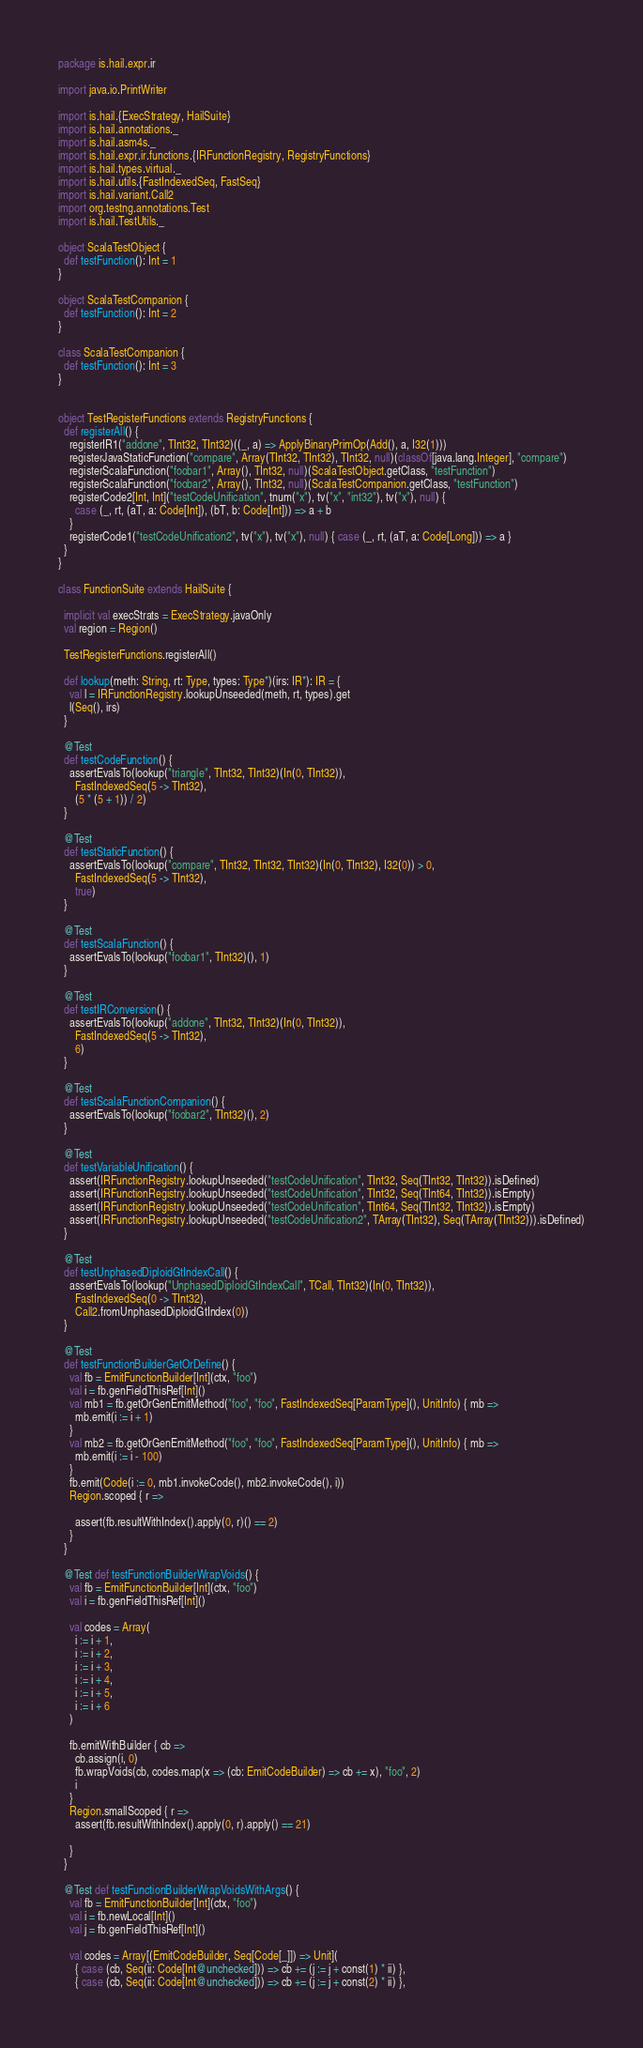<code> <loc_0><loc_0><loc_500><loc_500><_Scala_>package is.hail.expr.ir

import java.io.PrintWriter

import is.hail.{ExecStrategy, HailSuite}
import is.hail.annotations._
import is.hail.asm4s._
import is.hail.expr.ir.functions.{IRFunctionRegistry, RegistryFunctions}
import is.hail.types.virtual._
import is.hail.utils.{FastIndexedSeq, FastSeq}
import is.hail.variant.Call2
import org.testng.annotations.Test
import is.hail.TestUtils._

object ScalaTestObject {
  def testFunction(): Int = 1
}

object ScalaTestCompanion {
  def testFunction(): Int = 2
}

class ScalaTestCompanion {
  def testFunction(): Int = 3
}


object TestRegisterFunctions extends RegistryFunctions {
  def registerAll() {
    registerIR1("addone", TInt32, TInt32)((_, a) => ApplyBinaryPrimOp(Add(), a, I32(1)))
    registerJavaStaticFunction("compare", Array(TInt32, TInt32), TInt32, null)(classOf[java.lang.Integer], "compare")
    registerScalaFunction("foobar1", Array(), TInt32, null)(ScalaTestObject.getClass, "testFunction")
    registerScalaFunction("foobar2", Array(), TInt32, null)(ScalaTestCompanion.getClass, "testFunction")
    registerCode2[Int, Int]("testCodeUnification", tnum("x"), tv("x", "int32"), tv("x"), null) {
      case (_, rt, (aT, a: Code[Int]), (bT, b: Code[Int])) => a + b
    }
    registerCode1("testCodeUnification2", tv("x"), tv("x"), null) { case (_, rt, (aT, a: Code[Long])) => a }
  }
}

class FunctionSuite extends HailSuite {

  implicit val execStrats = ExecStrategy.javaOnly
  val region = Region()

  TestRegisterFunctions.registerAll()

  def lookup(meth: String, rt: Type, types: Type*)(irs: IR*): IR = {
    val l = IRFunctionRegistry.lookupUnseeded(meth, rt, types).get
    l(Seq(), irs)
  }

  @Test
  def testCodeFunction() {
    assertEvalsTo(lookup("triangle", TInt32, TInt32)(In(0, TInt32)),
      FastIndexedSeq(5 -> TInt32),
      (5 * (5 + 1)) / 2)
  }

  @Test
  def testStaticFunction() {
    assertEvalsTo(lookup("compare", TInt32, TInt32, TInt32)(In(0, TInt32), I32(0)) > 0,
      FastIndexedSeq(5 -> TInt32),
      true)
  }

  @Test
  def testScalaFunction() {
    assertEvalsTo(lookup("foobar1", TInt32)(), 1)
  }

  @Test
  def testIRConversion() {
    assertEvalsTo(lookup("addone", TInt32, TInt32)(In(0, TInt32)),
      FastIndexedSeq(5 -> TInt32),
      6)
  }

  @Test
  def testScalaFunctionCompanion() {
    assertEvalsTo(lookup("foobar2", TInt32)(), 2)
  }

  @Test
  def testVariableUnification() {
    assert(IRFunctionRegistry.lookupUnseeded("testCodeUnification", TInt32, Seq(TInt32, TInt32)).isDefined)
    assert(IRFunctionRegistry.lookupUnseeded("testCodeUnification", TInt32, Seq(TInt64, TInt32)).isEmpty)
    assert(IRFunctionRegistry.lookupUnseeded("testCodeUnification", TInt64, Seq(TInt32, TInt32)).isEmpty)
    assert(IRFunctionRegistry.lookupUnseeded("testCodeUnification2", TArray(TInt32), Seq(TArray(TInt32))).isDefined)
  }

  @Test
  def testUnphasedDiploidGtIndexCall() {
    assertEvalsTo(lookup("UnphasedDiploidGtIndexCall", TCall, TInt32)(In(0, TInt32)),
      FastIndexedSeq(0 -> TInt32),
      Call2.fromUnphasedDiploidGtIndex(0))
  }

  @Test
  def testFunctionBuilderGetOrDefine() {
    val fb = EmitFunctionBuilder[Int](ctx, "foo")
    val i = fb.genFieldThisRef[Int]()
    val mb1 = fb.getOrGenEmitMethod("foo", "foo", FastIndexedSeq[ParamType](), UnitInfo) { mb =>
      mb.emit(i := i + 1)
    }
    val mb2 = fb.getOrGenEmitMethod("foo", "foo", FastIndexedSeq[ParamType](), UnitInfo) { mb =>
      mb.emit(i := i - 100)
    }
    fb.emit(Code(i := 0, mb1.invokeCode(), mb2.invokeCode(), i))
    Region.scoped { r =>

      assert(fb.resultWithIndex().apply(0, r)() == 2)
    }
  }

  @Test def testFunctionBuilderWrapVoids() {
    val fb = EmitFunctionBuilder[Int](ctx, "foo")
    val i = fb.genFieldThisRef[Int]()

    val codes = Array(
      i := i + 1,
      i := i + 2,
      i := i + 3,
      i := i + 4,
      i := i + 5,
      i := i + 6
    )

    fb.emitWithBuilder { cb =>
      cb.assign(i, 0)
      fb.wrapVoids(cb, codes.map(x => (cb: EmitCodeBuilder) => cb += x), "foo", 2)
      i
    }
    Region.smallScoped { r =>
      assert(fb.resultWithIndex().apply(0, r).apply() == 21)

    }
  }

  @Test def testFunctionBuilderWrapVoidsWithArgs() {
    val fb = EmitFunctionBuilder[Int](ctx, "foo")
    val i = fb.newLocal[Int]()
    val j = fb.genFieldThisRef[Int]()

    val codes = Array[(EmitCodeBuilder, Seq[Code[_]]) => Unit](
      { case (cb, Seq(ii: Code[Int@unchecked])) => cb += (j := j + const(1) * ii) },
      { case (cb, Seq(ii: Code[Int@unchecked])) => cb += (j := j + const(2) * ii) },</code> 